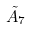<formula> <loc_0><loc_0><loc_500><loc_500>\tilde { A } _ { 7 }</formula> 